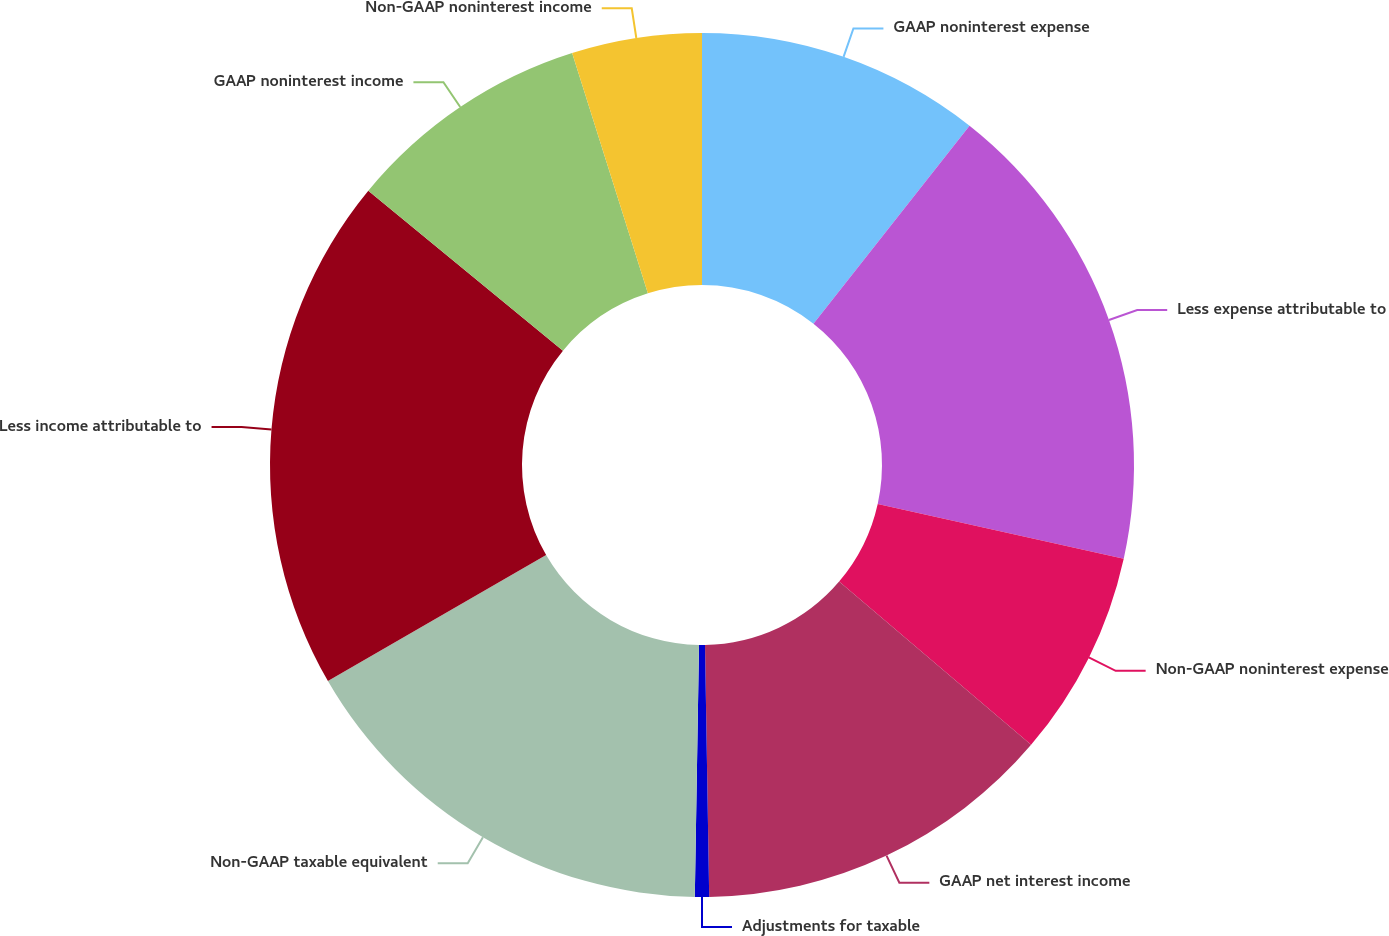Convert chart. <chart><loc_0><loc_0><loc_500><loc_500><pie_chart><fcel>GAAP noninterest expense<fcel>Less expense attributable to<fcel>Non-GAAP noninterest expense<fcel>GAAP net interest income<fcel>Adjustments for taxable<fcel>Non-GAAP taxable equivalent<fcel>Less income attributable to<fcel>GAAP noninterest income<fcel>Non-GAAP noninterest income<nl><fcel>10.63%<fcel>17.85%<fcel>7.74%<fcel>13.52%<fcel>0.53%<fcel>16.4%<fcel>19.29%<fcel>9.19%<fcel>4.86%<nl></chart> 